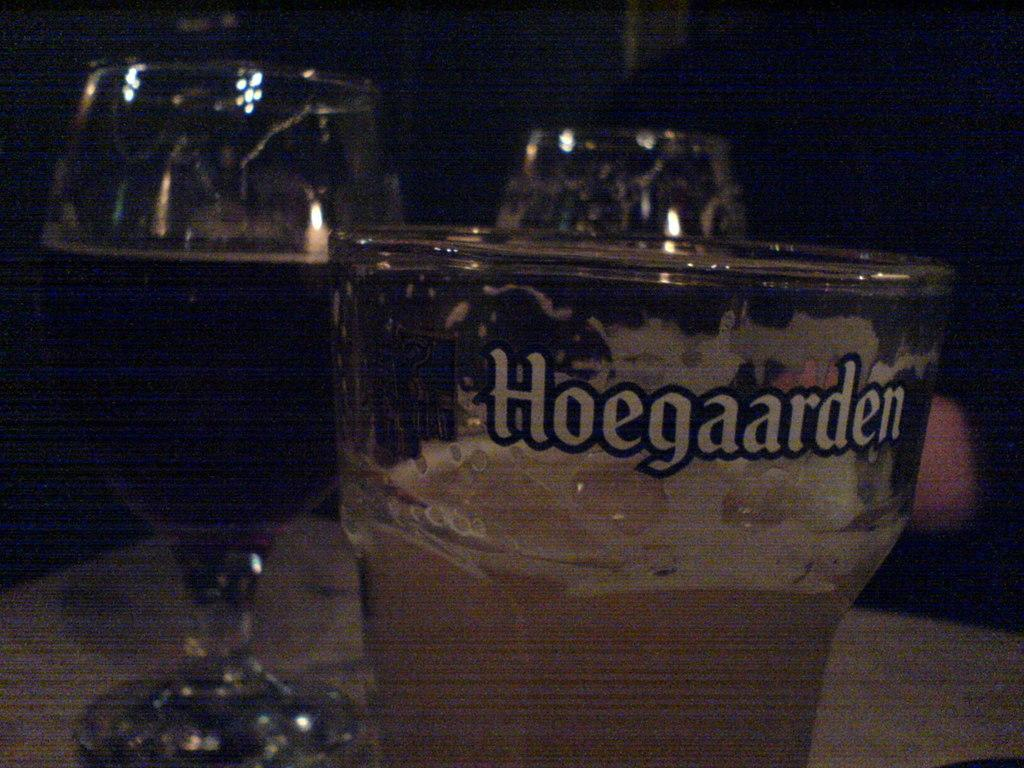<image>
Render a clear and concise summary of the photo. A shaken mixed liquor drink in a glass marked Hoegaarden. 